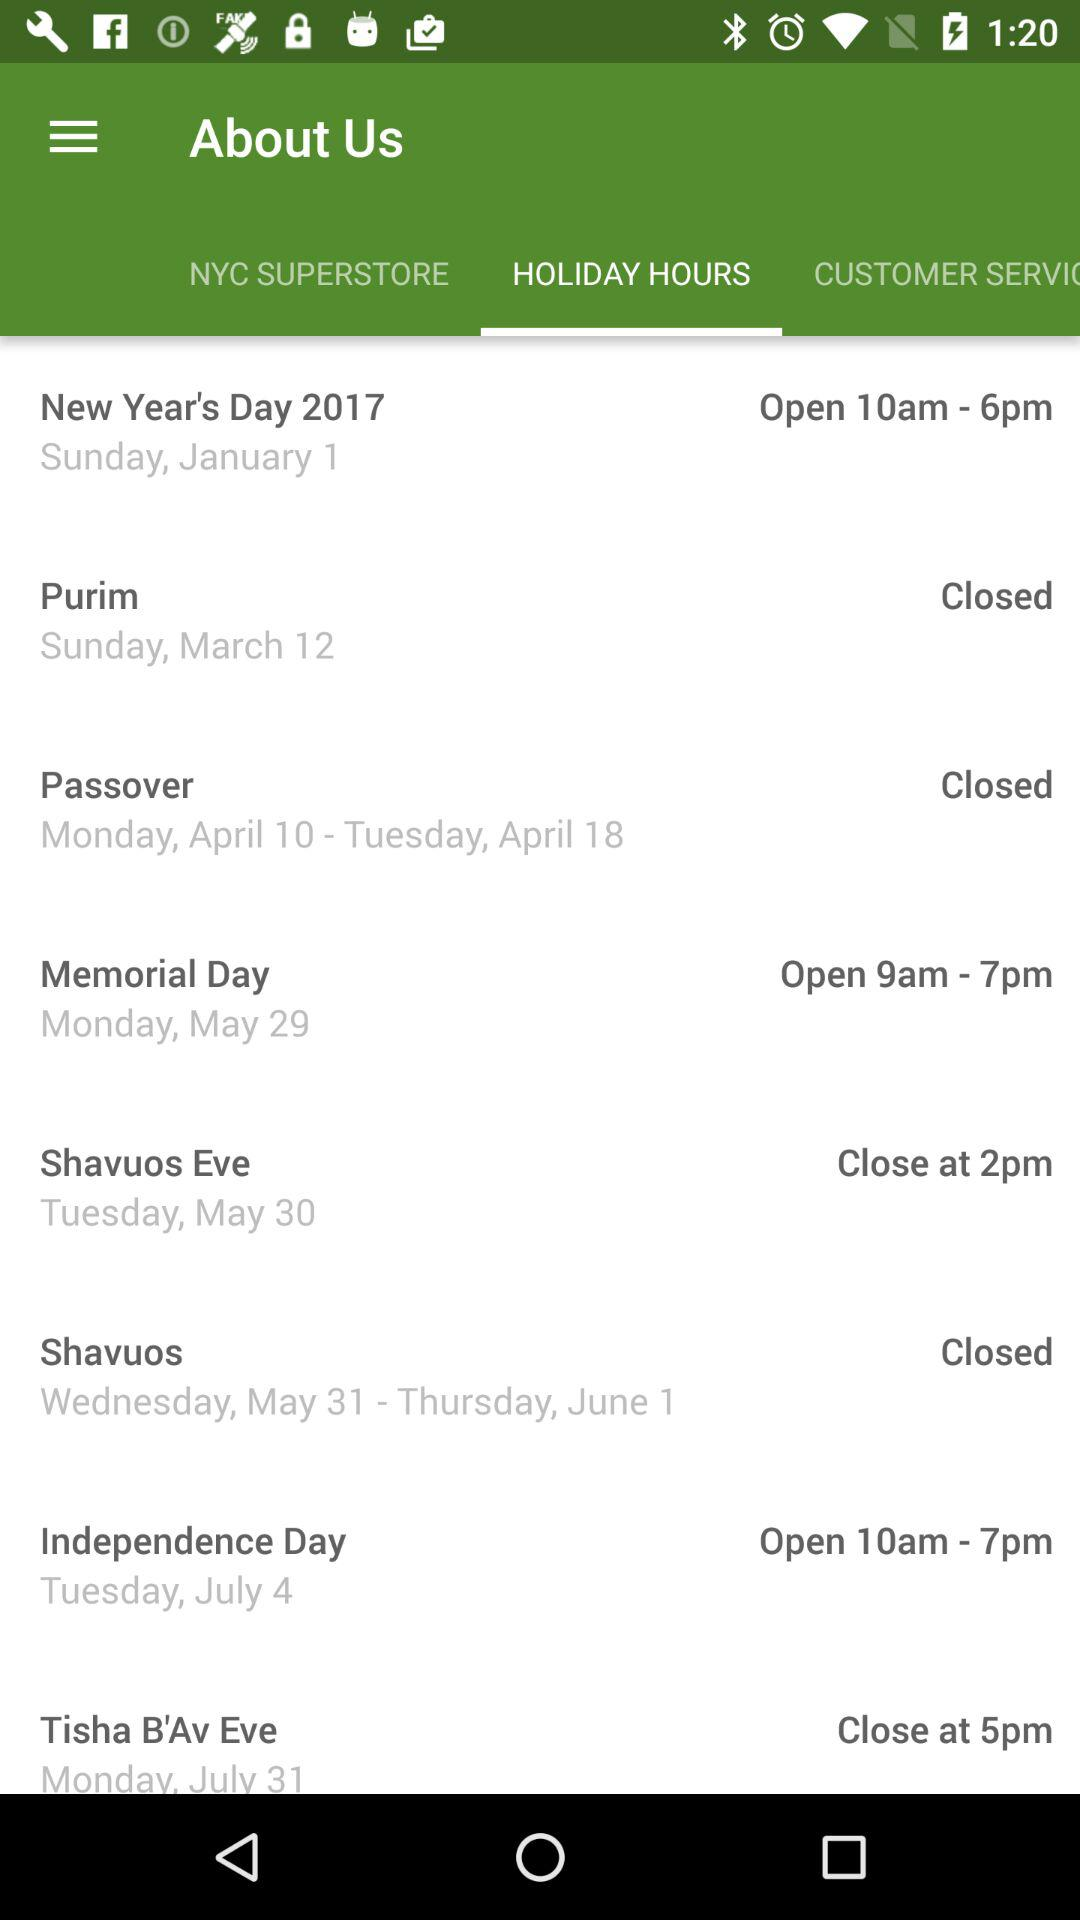When is Shavuos Eve? Shavuos Eve is on Tuesday, May 30. 